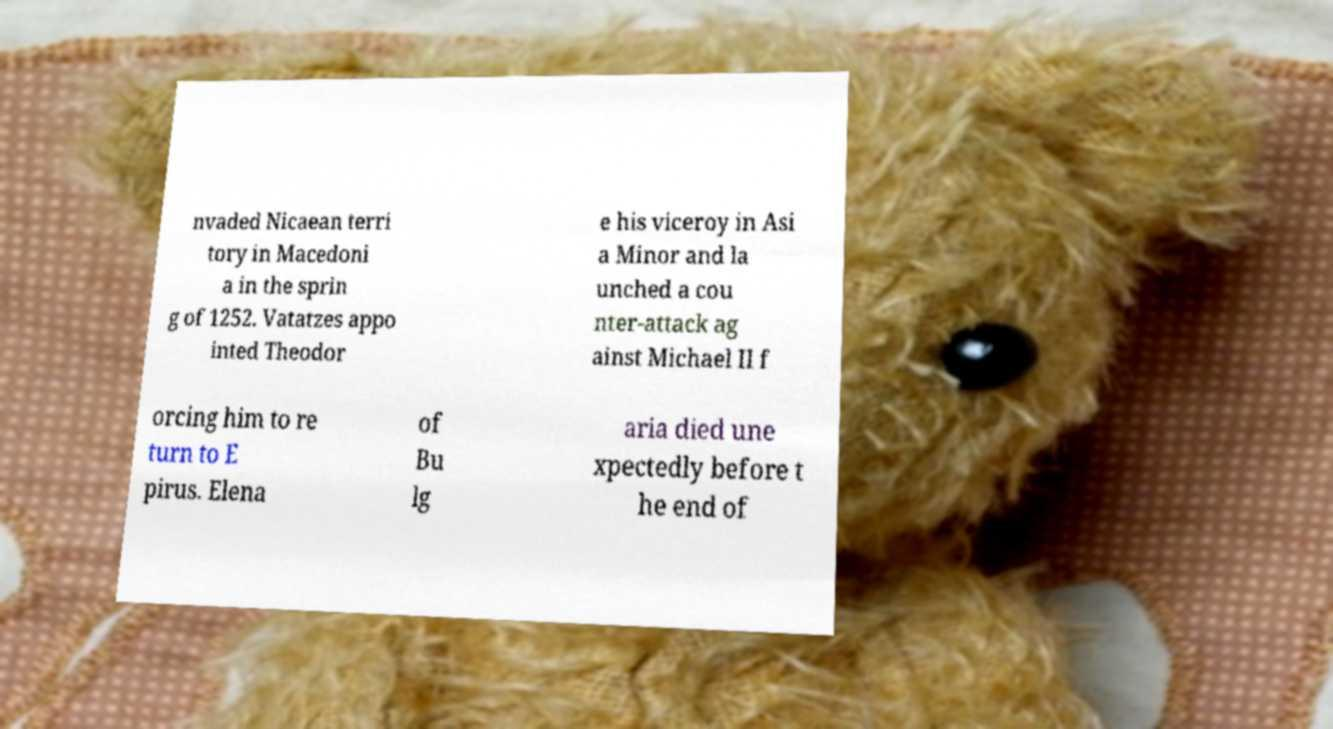Could you assist in decoding the text presented in this image and type it out clearly? nvaded Nicaean terri tory in Macedoni a in the sprin g of 1252. Vatatzes appo inted Theodor e his viceroy in Asi a Minor and la unched a cou nter-attack ag ainst Michael II f orcing him to re turn to E pirus. Elena of Bu lg aria died une xpectedly before t he end of 